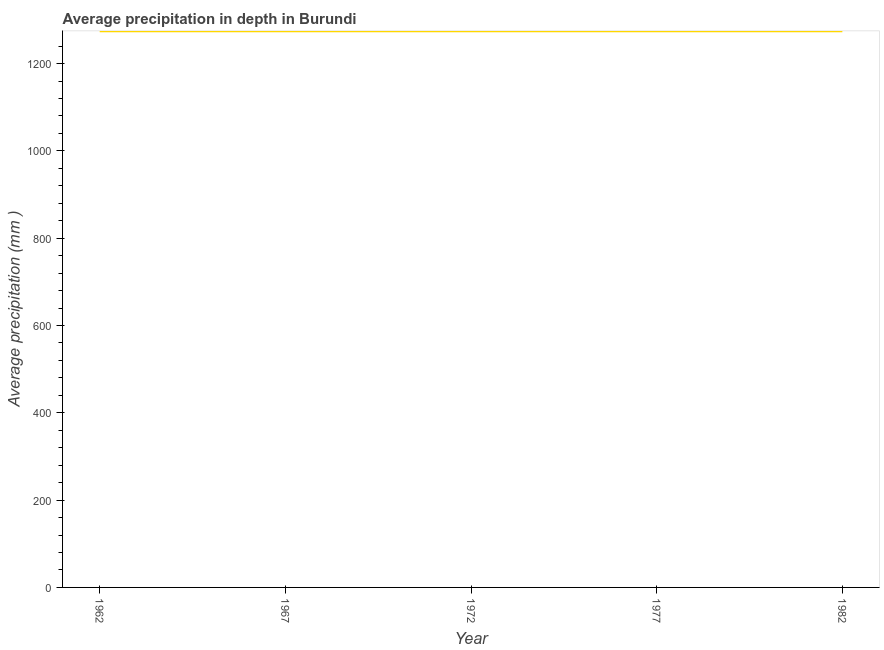What is the average precipitation in depth in 1967?
Give a very brief answer. 1274. Across all years, what is the maximum average precipitation in depth?
Your response must be concise. 1274. Across all years, what is the minimum average precipitation in depth?
Keep it short and to the point. 1274. What is the sum of the average precipitation in depth?
Make the answer very short. 6370. What is the difference between the average precipitation in depth in 1962 and 1967?
Your answer should be compact. 0. What is the average average precipitation in depth per year?
Make the answer very short. 1274. What is the median average precipitation in depth?
Offer a very short reply. 1274. Do a majority of the years between 1982 and 1962 (inclusive) have average precipitation in depth greater than 40 mm?
Your answer should be very brief. Yes. Is the average precipitation in depth in 1972 less than that in 1982?
Your answer should be very brief. No. What is the difference between the highest and the second highest average precipitation in depth?
Offer a very short reply. 0. Is the sum of the average precipitation in depth in 1967 and 1972 greater than the maximum average precipitation in depth across all years?
Your answer should be very brief. Yes. Does the average precipitation in depth monotonically increase over the years?
Your answer should be compact. No. How many lines are there?
Provide a succinct answer. 1. How many years are there in the graph?
Ensure brevity in your answer.  5. What is the difference between two consecutive major ticks on the Y-axis?
Your answer should be very brief. 200. Does the graph contain any zero values?
Keep it short and to the point. No. Does the graph contain grids?
Offer a terse response. No. What is the title of the graph?
Offer a terse response. Average precipitation in depth in Burundi. What is the label or title of the X-axis?
Keep it short and to the point. Year. What is the label or title of the Y-axis?
Provide a short and direct response. Average precipitation (mm ). What is the Average precipitation (mm ) of 1962?
Your answer should be compact. 1274. What is the Average precipitation (mm ) in 1967?
Your response must be concise. 1274. What is the Average precipitation (mm ) in 1972?
Keep it short and to the point. 1274. What is the Average precipitation (mm ) of 1977?
Offer a terse response. 1274. What is the Average precipitation (mm ) of 1982?
Ensure brevity in your answer.  1274. What is the difference between the Average precipitation (mm ) in 1962 and 1972?
Your answer should be very brief. 0. What is the difference between the Average precipitation (mm ) in 1962 and 1977?
Your response must be concise. 0. What is the difference between the Average precipitation (mm ) in 1972 and 1977?
Provide a short and direct response. 0. What is the difference between the Average precipitation (mm ) in 1972 and 1982?
Give a very brief answer. 0. What is the ratio of the Average precipitation (mm ) in 1962 to that in 1982?
Ensure brevity in your answer.  1. What is the ratio of the Average precipitation (mm ) in 1972 to that in 1982?
Keep it short and to the point. 1. What is the ratio of the Average precipitation (mm ) in 1977 to that in 1982?
Make the answer very short. 1. 